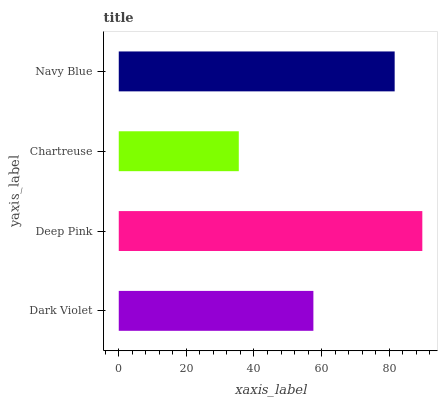Is Chartreuse the minimum?
Answer yes or no. Yes. Is Deep Pink the maximum?
Answer yes or no. Yes. Is Deep Pink the minimum?
Answer yes or no. No. Is Chartreuse the maximum?
Answer yes or no. No. Is Deep Pink greater than Chartreuse?
Answer yes or no. Yes. Is Chartreuse less than Deep Pink?
Answer yes or no. Yes. Is Chartreuse greater than Deep Pink?
Answer yes or no. No. Is Deep Pink less than Chartreuse?
Answer yes or no. No. Is Navy Blue the high median?
Answer yes or no. Yes. Is Dark Violet the low median?
Answer yes or no. Yes. Is Dark Violet the high median?
Answer yes or no. No. Is Navy Blue the low median?
Answer yes or no. No. 